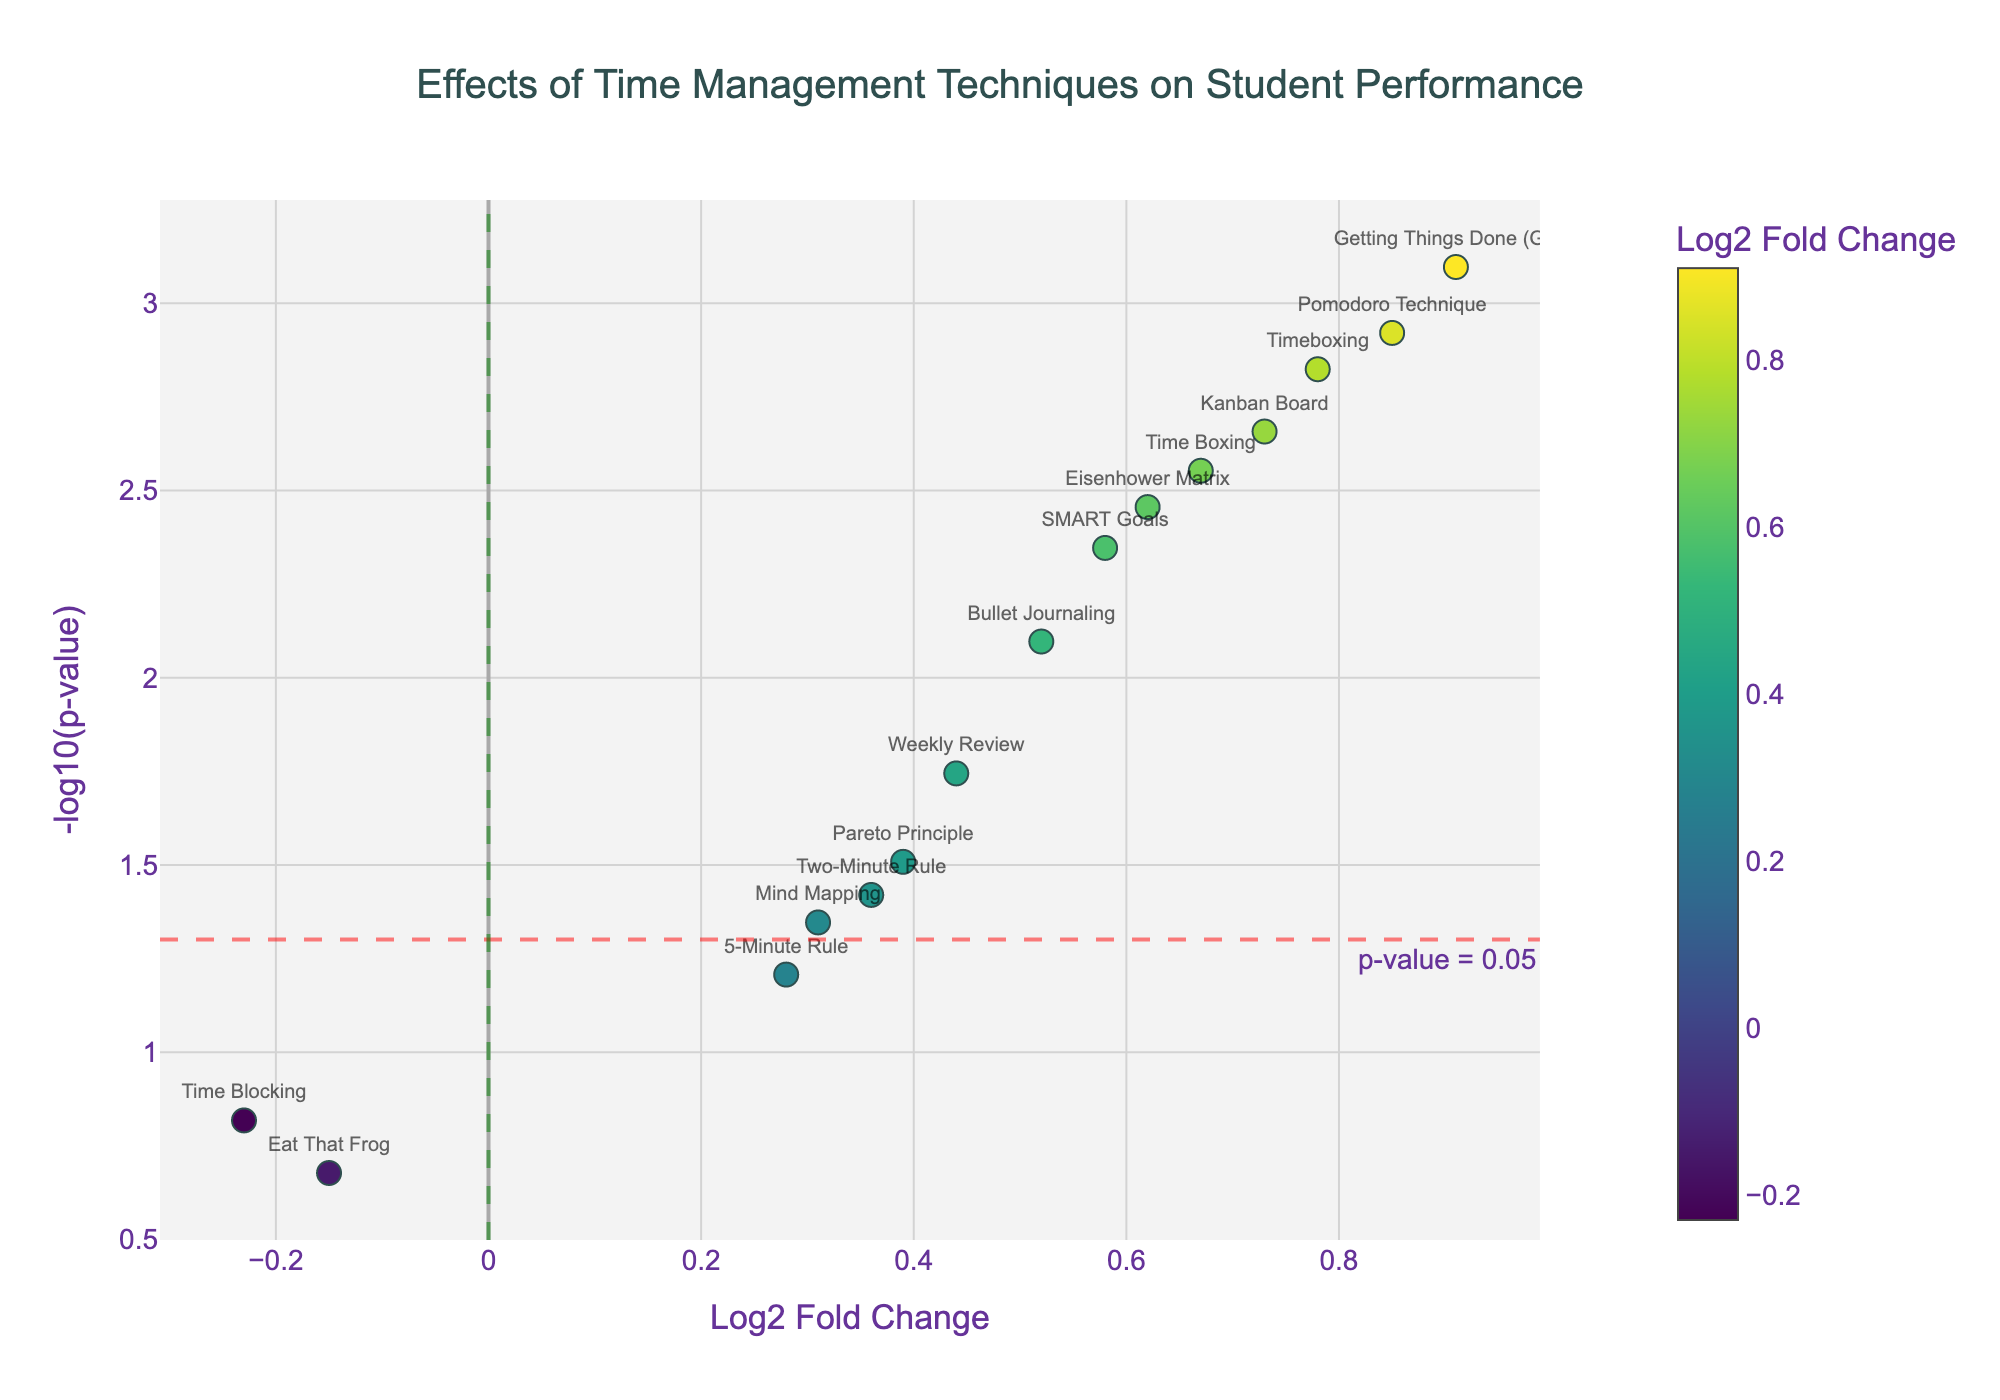What is the title of the plot? The title is located at the top center of the figure, which indicates the main topic of the visualization.
Answer: Effects of Time Management Techniques on Student Performance How many techniques are plotted on the graph? Each data point in the graph represents a different time management technique. Counting all the data points will give the number of techniques.
Answer: 14 Which technique has the highest log2 fold change? Find the technique corresponding to the data point with the highest value on the x-axis (log2 fold change).
Answer: Getting Things Done (GTD) What does the dashed red horizontal line represent? The dashed red horizontal line is labeled as "p-value = 0.05", indicating the significance threshold on the y-axis (-log10(p-value)).
Answer: p-value = 0.05 Which techniques show a log2 fold change greater than 0 and -log10(p-value) greater than 1.3? Identify the data points that are above the horizontal line at y = 1.3 (which corresponds to a p-value threshold of 0.05) and have a positive x-axis value (log2 fold change).
Answer: Pomodoro Technique, Eisenhower Matrix, Getting Things Done (GTD), Kanban Board, SMART Goals, Time Boxing, Bullet Journaling, Timeboxing, Weekly Review, Two-Minute Rule Which technique has the smallest p-value? Find the data point with the highest y-axis value (-log10(p-value)), as lower p-values correspond to higher -log10(p-value).
Answer: Getting Things Done (GTD) How many techniques have a significant effect (p-value < 0.05)? Examine the data points that are above the dashed red horizontal line, as it represents the threshold for significance (p-value of 0.05).
Answer: 10 Which techniques have a negative log2 fold change? Identify the data points that have a negative value on the x-axis (log2 fold change).
Answer: Time Blocking, Eat That Frog Among the techniques with a negative log2 fold change, which one is closest to zero on the y-axis? Look for the data point with a negative x-axis value (log2 fold change) that is closest to the x-axis (lowest -log10(p-value)).
Answer: Eat That Frog What color represents the highest log2 fold change on the plot? The color scale on the figure indicates that data points with higher log2 fold change values are represented by specific colors. Identify the color indicating the highest value.
Answer: The darkest color on the Viridis scale 